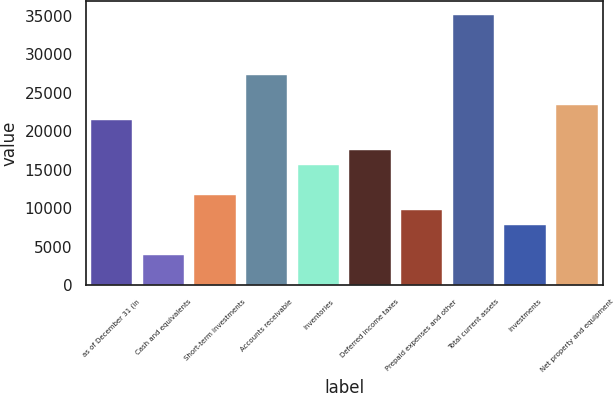Convert chart. <chart><loc_0><loc_0><loc_500><loc_500><bar_chart><fcel>as of December 31 (in<fcel>Cash and equivalents<fcel>Short-term investments<fcel>Accounts receivable<fcel>Inventories<fcel>Deferred income taxes<fcel>Prepaid expenses and other<fcel>Total current assets<fcel>Investments<fcel>Net property and equipment<nl><fcel>21471.5<fcel>3917<fcel>11719<fcel>27323<fcel>15620<fcel>17570.5<fcel>9768.5<fcel>35125<fcel>7818<fcel>23422<nl></chart> 